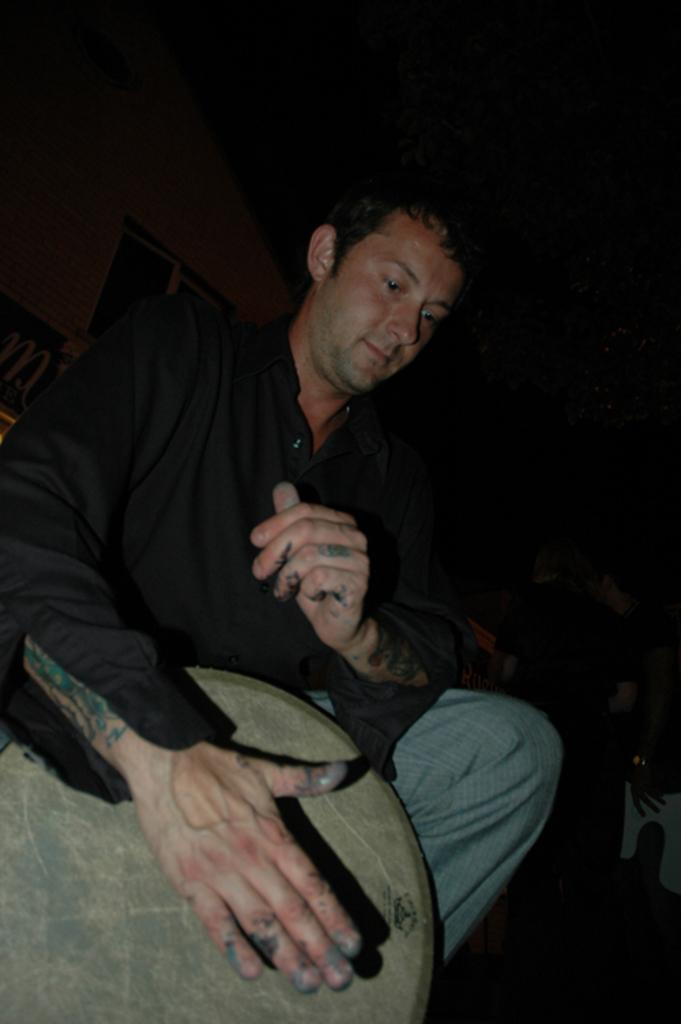What is the main subject of the image? The main subject of the image is a man. What is the man doing in the image? The man is playing a drum. What type of toy can be seen in the image? There is no toy present in the image; it features a man playing a drum. What kind of pancake is being prepared by the scarecrow in the image? There is no scarecrow or pancake present in the image; it only shows a man playing a drum. 